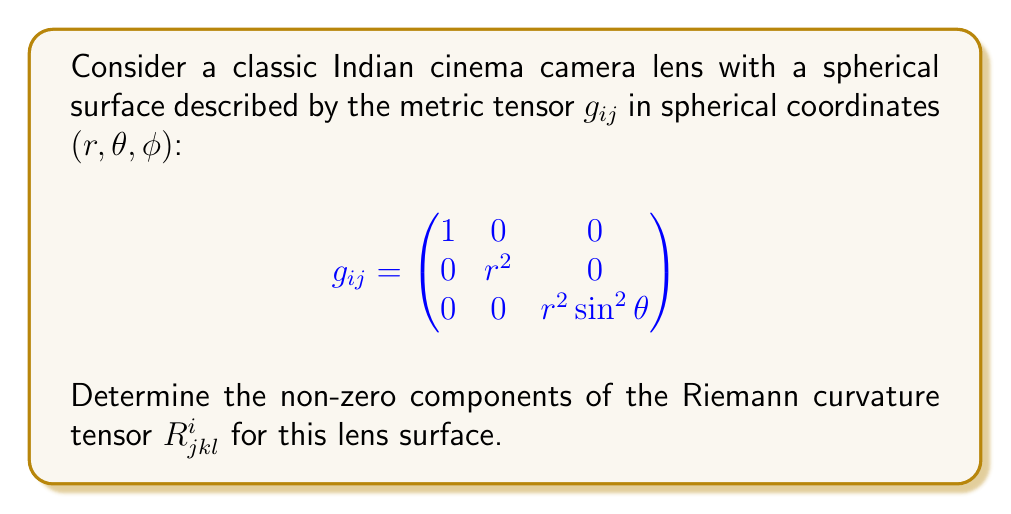Provide a solution to this math problem. To find the curvature tensor, we'll follow these steps:

1) First, calculate the Christoffel symbols $\Gamma^i_{jk}$ using:

   $$\Gamma^i_{jk} = \frac{1}{2}g^{im}(\partial_j g_{km} + \partial_k g_{jm} - \partial_m g_{jk})$$

2) The non-zero Christoffel symbols are:
   $$\Gamma^r_{\theta\theta} = -r$$
   $$\Gamma^r_{\phi\phi} = -r\sin^2\theta$$
   $$\Gamma^\theta_{r\theta} = \Gamma^\theta_{\theta r} = \frac{1}{r}$$
   $$\Gamma^\theta_{\phi\phi} = -\sin\theta\cos\theta$$
   $$\Gamma^\phi_{r\phi} = \Gamma^\phi_{\phi r} = \frac{1}{r}$$
   $$\Gamma^\phi_{\theta\phi} = \Gamma^\phi_{\phi\theta} = \cot\theta$$

3) Now, calculate the Riemann curvature tensor using:

   $$R^i_{jkl} = \partial_k \Gamma^i_{jl} - \partial_l \Gamma^i_{jk} + \Gamma^i_{mk}\Gamma^m_{jl} - \Gamma^i_{ml}\Gamma^m_{jk}$$

4) The non-zero components are:
   $$R^r_{\theta r \theta} = -1$$
   $$R^r_{\phi r \phi} = -\sin^2\theta$$
   $$R^\theta_{\phi \theta \phi} = -\sin^2\theta$$
   $$R^\phi_{\theta \phi \theta} = -1$$

5) All other components are either zero or can be obtained by symmetry relations of the Riemann tensor.
Answer: $R^r_{\theta r \theta} = -1$, $R^r_{\phi r \phi} = -\sin^2\theta$, $R^\theta_{\phi \theta \phi} = -\sin^2\theta$, $R^\phi_{\theta \phi \theta} = -1$ 